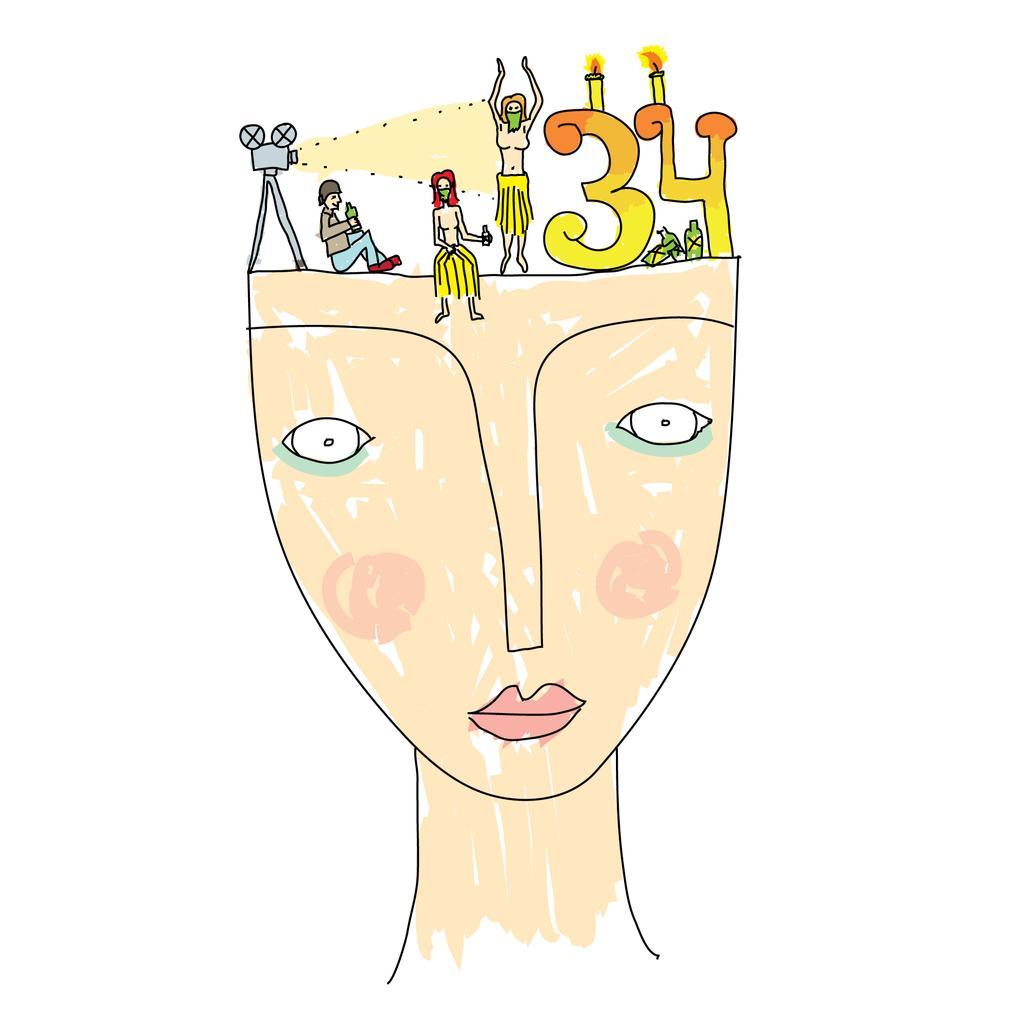In one or two sentences, can you explain what this image depicts? It is the drawing of an animated image. 